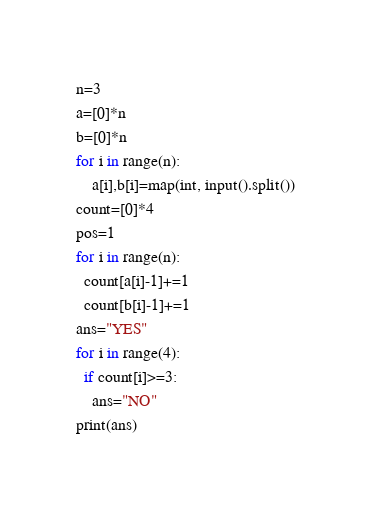<code> <loc_0><loc_0><loc_500><loc_500><_Python_>n=3
a=[0]*n
b=[0]*n
for i in range(n):
    a[i],b[i]=map(int, input().split())
count=[0]*4
pos=1
for i in range(n):
  count[a[i]-1]+=1
  count[b[i]-1]+=1
ans="YES"
for i in range(4):
  if count[i]>=3:
    ans="NO"
print(ans)</code> 